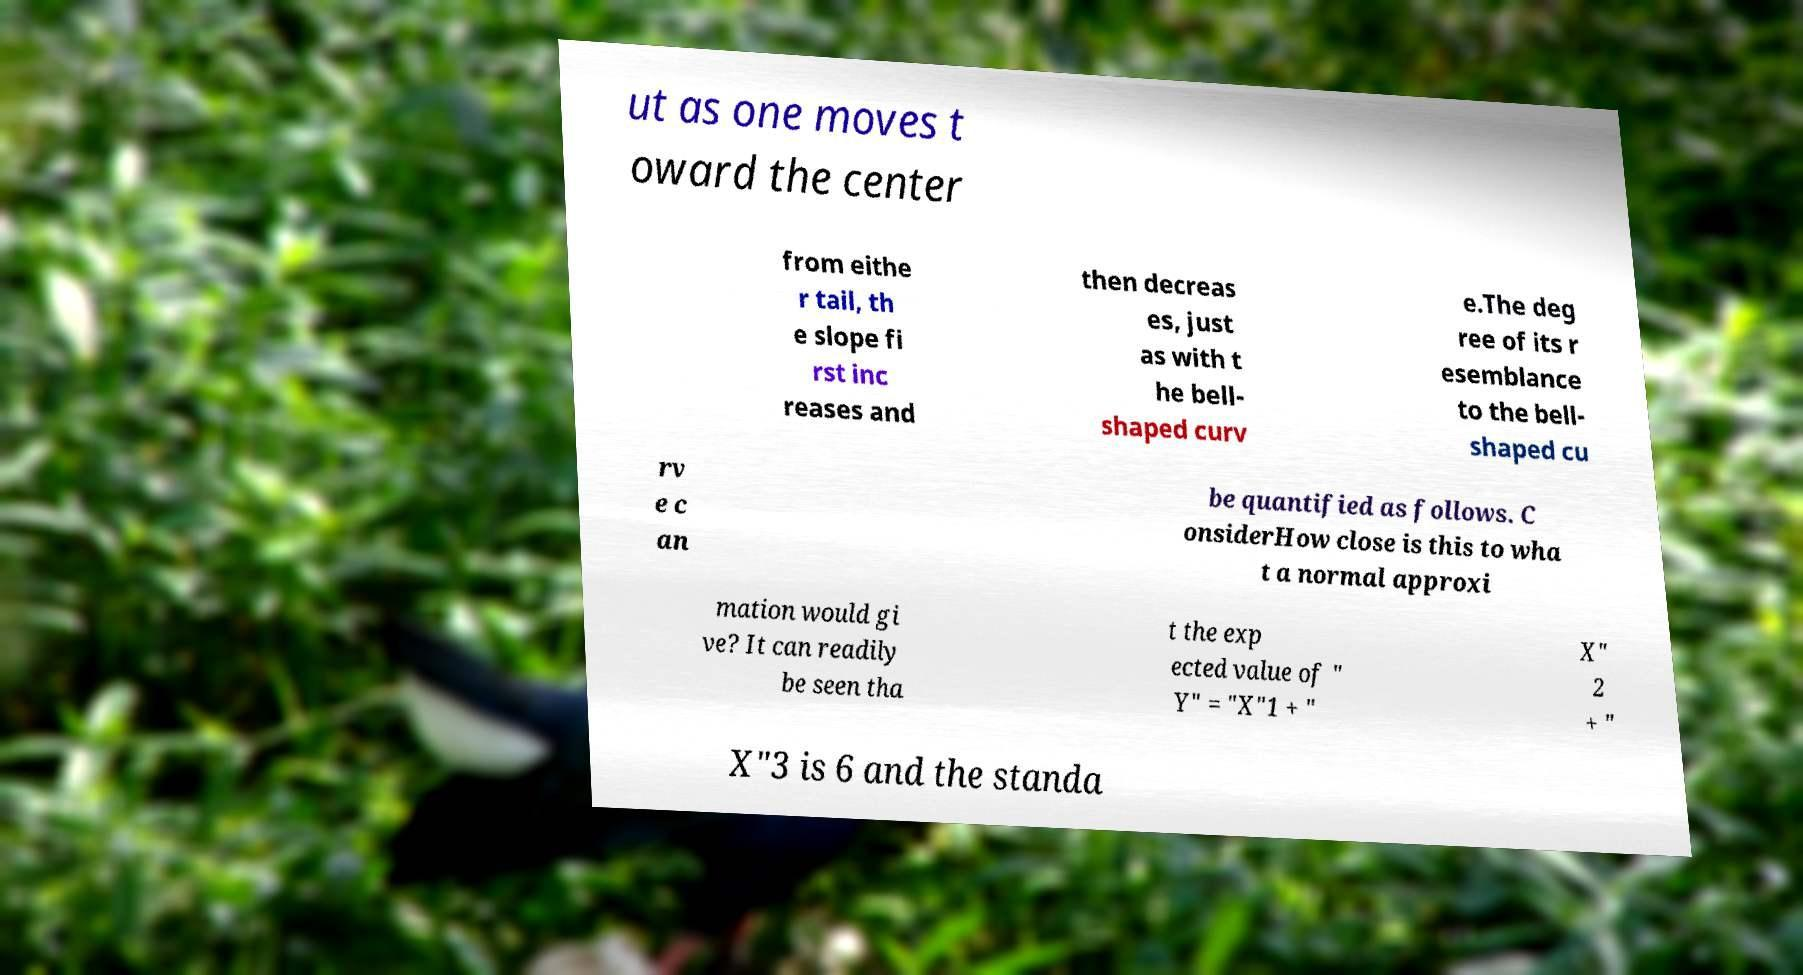Can you read and provide the text displayed in the image?This photo seems to have some interesting text. Can you extract and type it out for me? ut as one moves t oward the center from eithe r tail, th e slope fi rst inc reases and then decreas es, just as with t he bell- shaped curv e.The deg ree of its r esemblance to the bell- shaped cu rv e c an be quantified as follows. C onsiderHow close is this to wha t a normal approxi mation would gi ve? It can readily be seen tha t the exp ected value of " Y" = "X"1 + " X" 2 + " X"3 is 6 and the standa 